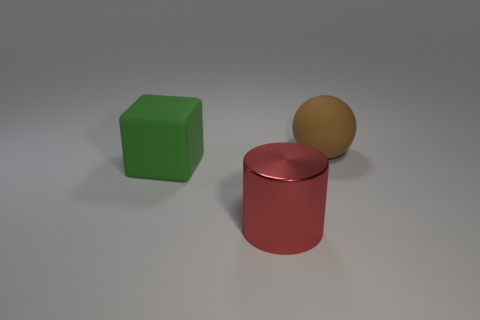Add 2 green rubber blocks. How many objects exist? 5 Add 3 large red things. How many large red things exist? 4 Subtract 1 brown spheres. How many objects are left? 2 Subtract all cylinders. How many objects are left? 2 Subtract all big cylinders. Subtract all big brown rubber balls. How many objects are left? 1 Add 3 cylinders. How many cylinders are left? 4 